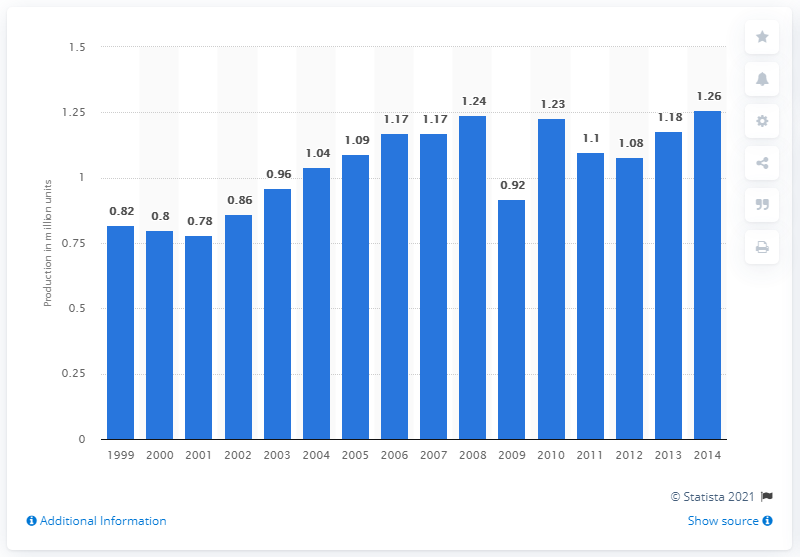Give some essential details in this illustration. In 2007, Mazda produced 1,180,000 passenger cars. 